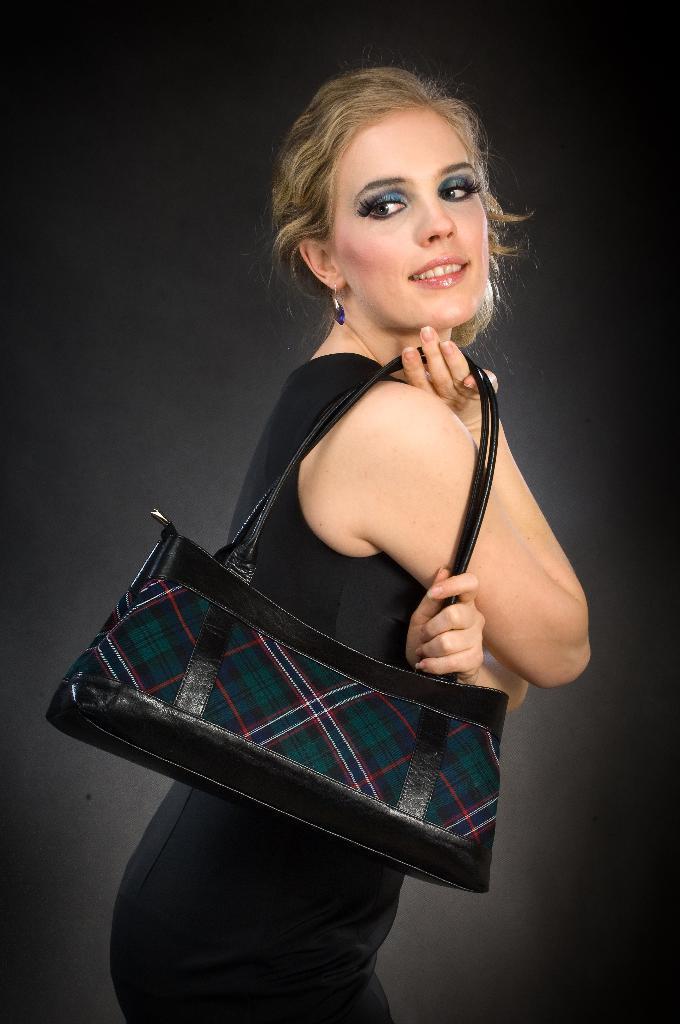Please provide a concise description of this image. In the picture we can find a woman wearing a handbag with black dress. In the background we can find a black wall. 